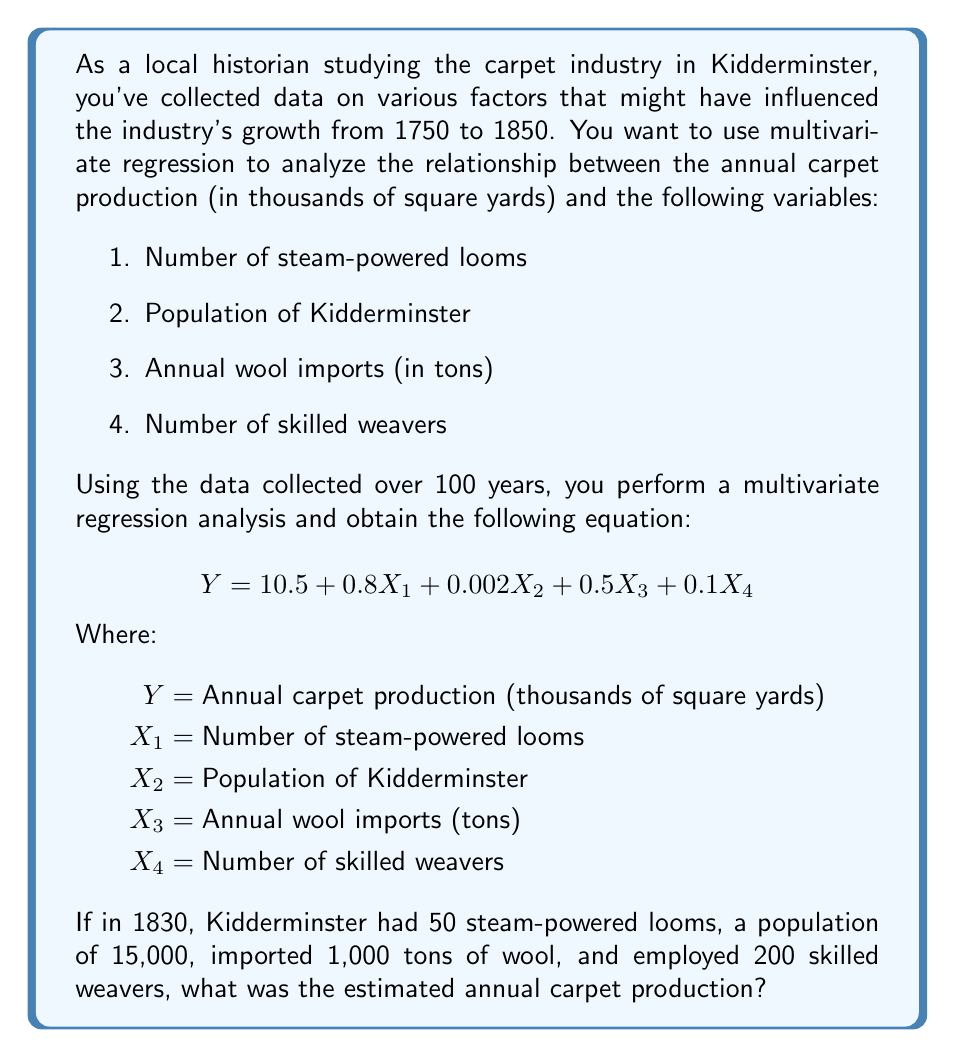What is the answer to this math problem? To solve this problem, we need to use the multivariate regression equation provided and substitute the given values for each variable. Let's break it down step-by-step:

1. Recall the regression equation:
   $$ Y = 10.5 + 0.8X_1 + 0.002X_2 + 0.5X_3 + 0.1X_4 $$

2. Substitute the given values:
   $X_1 = 50$ (steam-powered looms)
   $X_2 = 15,000$ (population)
   $X_3 = 1,000$ (tons of wool imported)
   $X_4 = 200$ (skilled weavers)

3. Now, let's plug these values into the equation:
   $$ Y = 10.5 + 0.8(50) + 0.002(15,000) + 0.5(1,000) + 0.1(200) $$

4. Let's calculate each term:
   $10.5$ (constant term)
   $0.8 \times 50 = 40$ (steam-powered looms)
   $0.002 \times 15,000 = 30$ (population)
   $0.5 \times 1,000 = 500$ (wool imports)
   $0.1 \times 200 = 20$ (skilled weavers)

5. Sum up all the terms:
   $$ Y = 10.5 + 40 + 30 + 500 + 20 $$

6. Calculate the final result:
   $$ Y = 600.5 $$

Therefore, the estimated annual carpet production in Kidderminster in 1830, based on the given multivariate regression model and data, was 600.5 thousand square yards.
Answer: 600.5 thousand square yards 